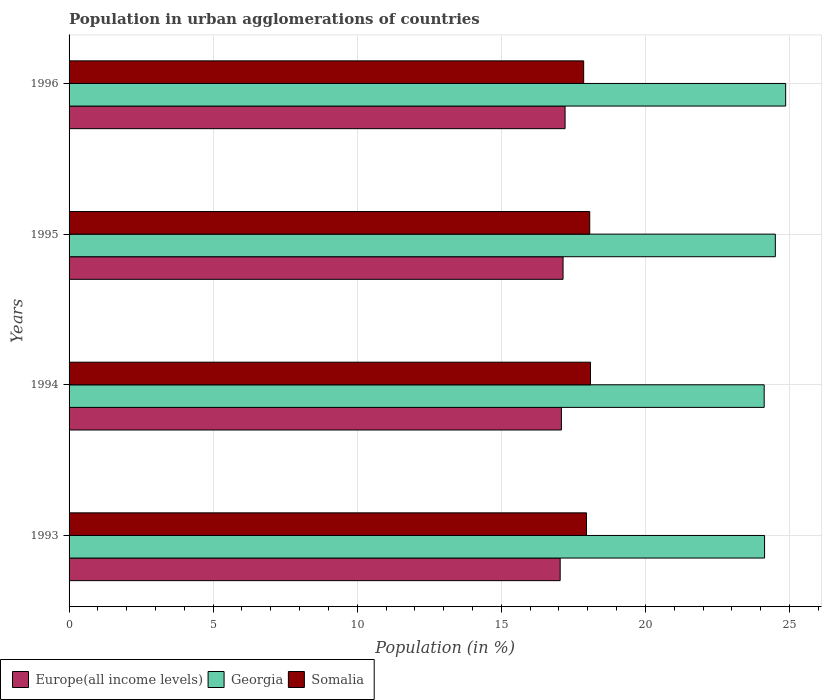How many different coloured bars are there?
Give a very brief answer. 3. How many groups of bars are there?
Provide a succinct answer. 4. Are the number of bars per tick equal to the number of legend labels?
Your answer should be compact. Yes. How many bars are there on the 2nd tick from the bottom?
Offer a terse response. 3. What is the label of the 3rd group of bars from the top?
Your answer should be very brief. 1994. In how many cases, is the number of bars for a given year not equal to the number of legend labels?
Offer a very short reply. 0. What is the percentage of population in urban agglomerations in Europe(all income levels) in 1993?
Your response must be concise. 17.04. Across all years, what is the maximum percentage of population in urban agglomerations in Somalia?
Your answer should be very brief. 18.09. Across all years, what is the minimum percentage of population in urban agglomerations in Europe(all income levels)?
Keep it short and to the point. 17.04. In which year was the percentage of population in urban agglomerations in Somalia minimum?
Your answer should be very brief. 1996. What is the total percentage of population in urban agglomerations in Somalia in the graph?
Provide a succinct answer. 71.97. What is the difference between the percentage of population in urban agglomerations in Somalia in 1994 and that in 1996?
Offer a terse response. 0.24. What is the difference between the percentage of population in urban agglomerations in Georgia in 1993 and the percentage of population in urban agglomerations in Somalia in 1994?
Offer a very short reply. 6.04. What is the average percentage of population in urban agglomerations in Georgia per year?
Provide a short and direct response. 24.41. In the year 1995, what is the difference between the percentage of population in urban agglomerations in Somalia and percentage of population in urban agglomerations in Europe(all income levels)?
Your response must be concise. 0.93. What is the ratio of the percentage of population in urban agglomerations in Georgia in 1995 to that in 1996?
Make the answer very short. 0.99. Is the difference between the percentage of population in urban agglomerations in Somalia in 1994 and 1996 greater than the difference between the percentage of population in urban agglomerations in Europe(all income levels) in 1994 and 1996?
Your response must be concise. Yes. What is the difference between the highest and the second highest percentage of population in urban agglomerations in Somalia?
Your answer should be compact. 0.03. What is the difference between the highest and the lowest percentage of population in urban agglomerations in Somalia?
Offer a terse response. 0.24. In how many years, is the percentage of population in urban agglomerations in Somalia greater than the average percentage of population in urban agglomerations in Somalia taken over all years?
Provide a short and direct response. 2. What does the 2nd bar from the top in 1996 represents?
Offer a very short reply. Georgia. What does the 1st bar from the bottom in 1996 represents?
Make the answer very short. Europe(all income levels). Is it the case that in every year, the sum of the percentage of population in urban agglomerations in Somalia and percentage of population in urban agglomerations in Georgia is greater than the percentage of population in urban agglomerations in Europe(all income levels)?
Keep it short and to the point. Yes. Are all the bars in the graph horizontal?
Provide a succinct answer. Yes. Are the values on the major ticks of X-axis written in scientific E-notation?
Provide a short and direct response. No. Does the graph contain any zero values?
Provide a short and direct response. No. Where does the legend appear in the graph?
Make the answer very short. Bottom left. How are the legend labels stacked?
Your response must be concise. Horizontal. What is the title of the graph?
Your answer should be compact. Population in urban agglomerations of countries. What is the label or title of the X-axis?
Your answer should be compact. Population (in %). What is the Population (in %) in Europe(all income levels) in 1993?
Make the answer very short. 17.04. What is the Population (in %) of Georgia in 1993?
Provide a short and direct response. 24.13. What is the Population (in %) in Somalia in 1993?
Your answer should be compact. 17.95. What is the Population (in %) of Europe(all income levels) in 1994?
Offer a very short reply. 17.08. What is the Population (in %) in Georgia in 1994?
Offer a terse response. 24.12. What is the Population (in %) of Somalia in 1994?
Make the answer very short. 18.09. What is the Population (in %) of Europe(all income levels) in 1995?
Your answer should be very brief. 17.14. What is the Population (in %) in Georgia in 1995?
Provide a succinct answer. 24.51. What is the Population (in %) of Somalia in 1995?
Offer a very short reply. 18.07. What is the Population (in %) in Europe(all income levels) in 1996?
Make the answer very short. 17.21. What is the Population (in %) in Georgia in 1996?
Your answer should be compact. 24.87. What is the Population (in %) of Somalia in 1996?
Your response must be concise. 17.86. Across all years, what is the maximum Population (in %) in Europe(all income levels)?
Your answer should be very brief. 17.21. Across all years, what is the maximum Population (in %) in Georgia?
Offer a terse response. 24.87. Across all years, what is the maximum Population (in %) in Somalia?
Ensure brevity in your answer.  18.09. Across all years, what is the minimum Population (in %) in Europe(all income levels)?
Keep it short and to the point. 17.04. Across all years, what is the minimum Population (in %) in Georgia?
Your answer should be very brief. 24.12. Across all years, what is the minimum Population (in %) of Somalia?
Give a very brief answer. 17.86. What is the total Population (in %) in Europe(all income levels) in the graph?
Offer a terse response. 68.48. What is the total Population (in %) in Georgia in the graph?
Offer a terse response. 97.63. What is the total Population (in %) in Somalia in the graph?
Your answer should be compact. 71.97. What is the difference between the Population (in %) of Europe(all income levels) in 1993 and that in 1994?
Keep it short and to the point. -0.04. What is the difference between the Population (in %) of Georgia in 1993 and that in 1994?
Ensure brevity in your answer.  0.01. What is the difference between the Population (in %) of Somalia in 1993 and that in 1994?
Provide a succinct answer. -0.14. What is the difference between the Population (in %) of Europe(all income levels) in 1993 and that in 1995?
Provide a short and direct response. -0.1. What is the difference between the Population (in %) in Georgia in 1993 and that in 1995?
Offer a terse response. -0.37. What is the difference between the Population (in %) in Somalia in 1993 and that in 1995?
Provide a succinct answer. -0.11. What is the difference between the Population (in %) of Europe(all income levels) in 1993 and that in 1996?
Offer a terse response. -0.17. What is the difference between the Population (in %) in Georgia in 1993 and that in 1996?
Make the answer very short. -0.73. What is the difference between the Population (in %) of Somalia in 1993 and that in 1996?
Provide a succinct answer. 0.1. What is the difference between the Population (in %) of Europe(all income levels) in 1994 and that in 1995?
Provide a succinct answer. -0.06. What is the difference between the Population (in %) in Georgia in 1994 and that in 1995?
Your answer should be very brief. -0.39. What is the difference between the Population (in %) of Somalia in 1994 and that in 1995?
Your answer should be very brief. 0.03. What is the difference between the Population (in %) of Europe(all income levels) in 1994 and that in 1996?
Ensure brevity in your answer.  -0.13. What is the difference between the Population (in %) in Georgia in 1994 and that in 1996?
Your response must be concise. -0.75. What is the difference between the Population (in %) of Somalia in 1994 and that in 1996?
Give a very brief answer. 0.24. What is the difference between the Population (in %) in Europe(all income levels) in 1995 and that in 1996?
Ensure brevity in your answer.  -0.07. What is the difference between the Population (in %) of Georgia in 1995 and that in 1996?
Your response must be concise. -0.36. What is the difference between the Population (in %) in Somalia in 1995 and that in 1996?
Offer a terse response. 0.21. What is the difference between the Population (in %) of Europe(all income levels) in 1993 and the Population (in %) of Georgia in 1994?
Provide a short and direct response. -7.08. What is the difference between the Population (in %) in Europe(all income levels) in 1993 and the Population (in %) in Somalia in 1994?
Your answer should be compact. -1.05. What is the difference between the Population (in %) of Georgia in 1993 and the Population (in %) of Somalia in 1994?
Keep it short and to the point. 6.04. What is the difference between the Population (in %) in Europe(all income levels) in 1993 and the Population (in %) in Georgia in 1995?
Your answer should be very brief. -7.47. What is the difference between the Population (in %) in Europe(all income levels) in 1993 and the Population (in %) in Somalia in 1995?
Give a very brief answer. -1.03. What is the difference between the Population (in %) of Georgia in 1993 and the Population (in %) of Somalia in 1995?
Provide a short and direct response. 6.07. What is the difference between the Population (in %) of Europe(all income levels) in 1993 and the Population (in %) of Georgia in 1996?
Your answer should be compact. -7.82. What is the difference between the Population (in %) in Europe(all income levels) in 1993 and the Population (in %) in Somalia in 1996?
Keep it short and to the point. -0.82. What is the difference between the Population (in %) in Georgia in 1993 and the Population (in %) in Somalia in 1996?
Your answer should be very brief. 6.28. What is the difference between the Population (in %) in Europe(all income levels) in 1994 and the Population (in %) in Georgia in 1995?
Give a very brief answer. -7.42. What is the difference between the Population (in %) of Europe(all income levels) in 1994 and the Population (in %) of Somalia in 1995?
Keep it short and to the point. -0.98. What is the difference between the Population (in %) of Georgia in 1994 and the Population (in %) of Somalia in 1995?
Your response must be concise. 6.05. What is the difference between the Population (in %) in Europe(all income levels) in 1994 and the Population (in %) in Georgia in 1996?
Give a very brief answer. -7.78. What is the difference between the Population (in %) of Europe(all income levels) in 1994 and the Population (in %) of Somalia in 1996?
Keep it short and to the point. -0.77. What is the difference between the Population (in %) of Georgia in 1994 and the Population (in %) of Somalia in 1996?
Keep it short and to the point. 6.26. What is the difference between the Population (in %) in Europe(all income levels) in 1995 and the Population (in %) in Georgia in 1996?
Ensure brevity in your answer.  -7.72. What is the difference between the Population (in %) of Europe(all income levels) in 1995 and the Population (in %) of Somalia in 1996?
Make the answer very short. -0.72. What is the difference between the Population (in %) in Georgia in 1995 and the Population (in %) in Somalia in 1996?
Your response must be concise. 6.65. What is the average Population (in %) in Europe(all income levels) per year?
Your answer should be very brief. 17.12. What is the average Population (in %) in Georgia per year?
Your answer should be compact. 24.41. What is the average Population (in %) of Somalia per year?
Offer a very short reply. 17.99. In the year 1993, what is the difference between the Population (in %) of Europe(all income levels) and Population (in %) of Georgia?
Your response must be concise. -7.09. In the year 1993, what is the difference between the Population (in %) in Europe(all income levels) and Population (in %) in Somalia?
Offer a terse response. -0.91. In the year 1993, what is the difference between the Population (in %) in Georgia and Population (in %) in Somalia?
Give a very brief answer. 6.18. In the year 1994, what is the difference between the Population (in %) of Europe(all income levels) and Population (in %) of Georgia?
Provide a short and direct response. -7.04. In the year 1994, what is the difference between the Population (in %) in Europe(all income levels) and Population (in %) in Somalia?
Offer a terse response. -1.01. In the year 1994, what is the difference between the Population (in %) of Georgia and Population (in %) of Somalia?
Offer a terse response. 6.03. In the year 1995, what is the difference between the Population (in %) of Europe(all income levels) and Population (in %) of Georgia?
Provide a short and direct response. -7.37. In the year 1995, what is the difference between the Population (in %) of Europe(all income levels) and Population (in %) of Somalia?
Provide a short and direct response. -0.93. In the year 1995, what is the difference between the Population (in %) in Georgia and Population (in %) in Somalia?
Offer a very short reply. 6.44. In the year 1996, what is the difference between the Population (in %) of Europe(all income levels) and Population (in %) of Georgia?
Keep it short and to the point. -7.65. In the year 1996, what is the difference between the Population (in %) in Europe(all income levels) and Population (in %) in Somalia?
Provide a short and direct response. -0.65. In the year 1996, what is the difference between the Population (in %) of Georgia and Population (in %) of Somalia?
Provide a succinct answer. 7.01. What is the ratio of the Population (in %) in Europe(all income levels) in 1993 to that in 1994?
Offer a very short reply. 1. What is the ratio of the Population (in %) in Somalia in 1993 to that in 1994?
Provide a short and direct response. 0.99. What is the ratio of the Population (in %) of Georgia in 1993 to that in 1995?
Offer a terse response. 0.98. What is the ratio of the Population (in %) of Georgia in 1993 to that in 1996?
Ensure brevity in your answer.  0.97. What is the ratio of the Population (in %) in Somalia in 1993 to that in 1996?
Give a very brief answer. 1.01. What is the ratio of the Population (in %) of Georgia in 1994 to that in 1995?
Make the answer very short. 0.98. What is the ratio of the Population (in %) in Georgia in 1994 to that in 1996?
Ensure brevity in your answer.  0.97. What is the ratio of the Population (in %) of Somalia in 1994 to that in 1996?
Offer a terse response. 1.01. What is the ratio of the Population (in %) in Georgia in 1995 to that in 1996?
Your answer should be very brief. 0.99. What is the ratio of the Population (in %) of Somalia in 1995 to that in 1996?
Make the answer very short. 1.01. What is the difference between the highest and the second highest Population (in %) in Europe(all income levels)?
Your response must be concise. 0.07. What is the difference between the highest and the second highest Population (in %) of Georgia?
Your answer should be very brief. 0.36. What is the difference between the highest and the second highest Population (in %) in Somalia?
Your response must be concise. 0.03. What is the difference between the highest and the lowest Population (in %) in Europe(all income levels)?
Provide a short and direct response. 0.17. What is the difference between the highest and the lowest Population (in %) of Georgia?
Your answer should be very brief. 0.75. What is the difference between the highest and the lowest Population (in %) in Somalia?
Give a very brief answer. 0.24. 